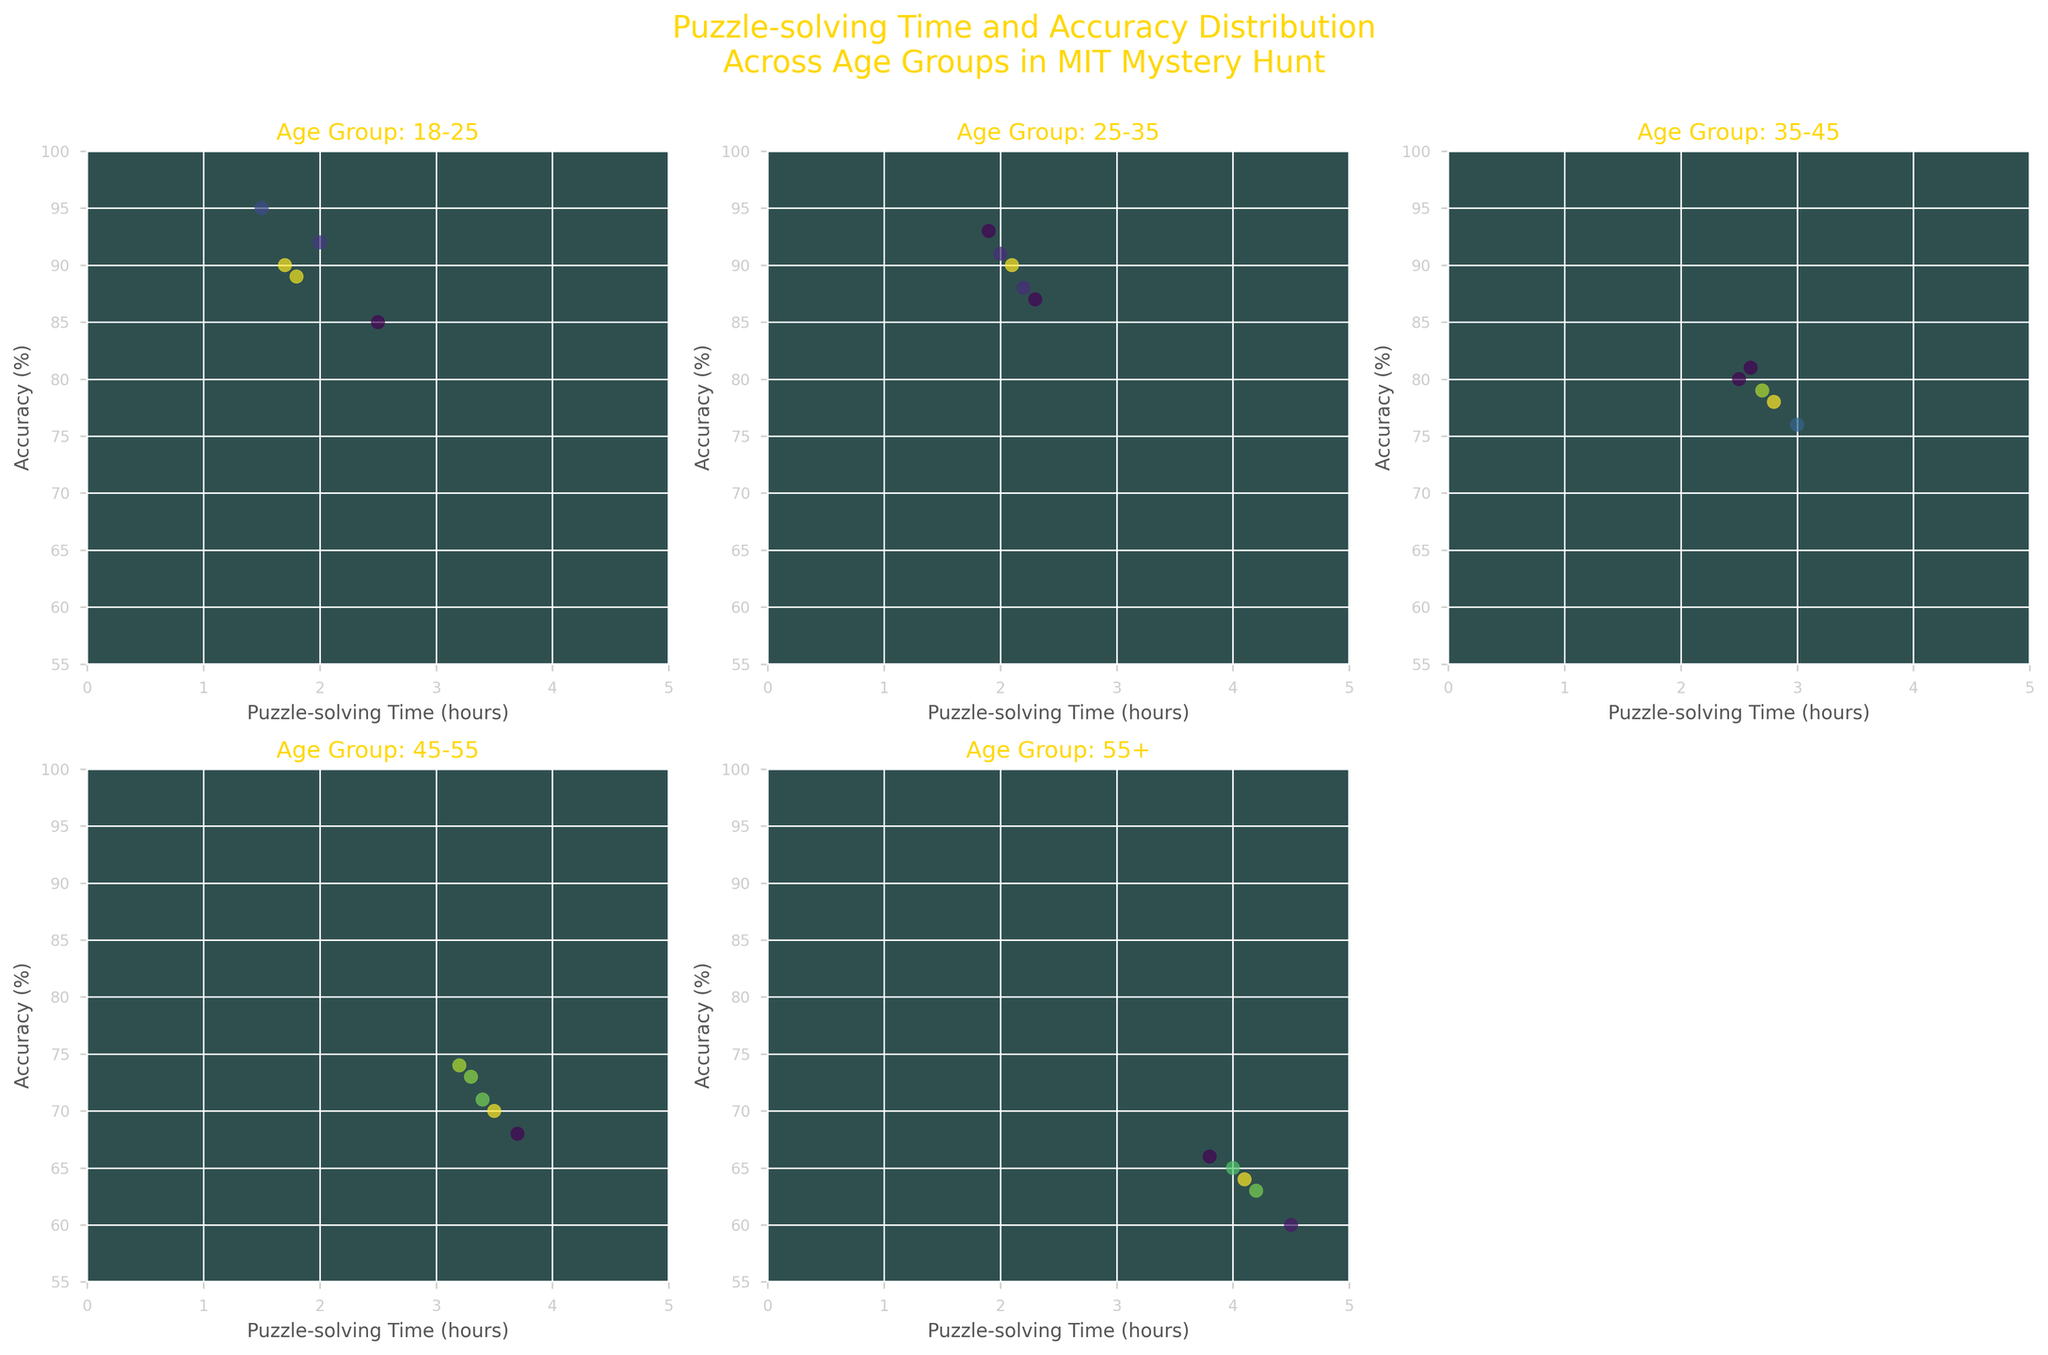What is the title of the figure? The title is usually located at the top of the figure. For this particular figure, it is "Puzzle-solving Time and Accuracy Distribution Across Age Groups in MIT Mystery Hunt" as generated in the code.
Answer: Puzzle-solving Time and Accuracy Distribution Across Age Groups in MIT Mystery Hunt What is the age group with the quickest puzzle-solving time on average? By visually inspecting the scatter plots, the 18-25 age group appears to have the quickest puzzle-solving times, as their data points are concentrated towards lower hours on the x-axis.
Answer: 18-25 Which age group has the most spread in puzzle-solving times? The 55+ age group shows a wider range of puzzle-solving times from 3.8 to 4.5 hours, indicating the most spread compared to other age groups. This can be seen by the distribution of their data points along the x-axis.
Answer: 55+ What is the axis label for the y-axis? The y-axis label is commonly placed to the left side of the figure. According to the code, the y-axis label is "Accuracy (%)".
Answer: Accuracy (%) Are any subplots left empty, and if so, which one? By looking at the figure, the bottom right subplot (axs[1, 2]) is intentionally left empty as coded.
Answer: Bottom right Which age group has consistently higher accuracy in their puzzle-solving? The 18-25 age group has higher accuracy percentages consistently compared to other age groups, as evidenced by their data points being situated higher on the y-axis.
Answer: 18-25 What's the maximum accuracy percentage observed for any age group? By examining the y-axis across all scatter plots, the maximum accuracy percentage observed is 95% for the 18-25 age group.
Answer: 95% How does the accuracy trend change as age groups increase? Evaluating the subplots, it's noticeable that as age groups increase, accuracy percentages tend to decrease, indicated by a downward shift in data points on the y-axis.
Answer: Decreases Which age group demonstrates the highest density of data points? Utilizing the color gradient demonstrating point density, the 18-25 age group shows a higher density of data points within the 1.5 to 2.0 hours range on the x-axis and above 85% on the y-axis.
Answer: 18-25 What range of puzzle-solving times is observed for the 35-45 age group? Observing the scatter plot for this age group, puzzle-solving times range from 2.5 to 3.0 hours on the x-axis.
Answer: 2.5 to 3.0 hours 